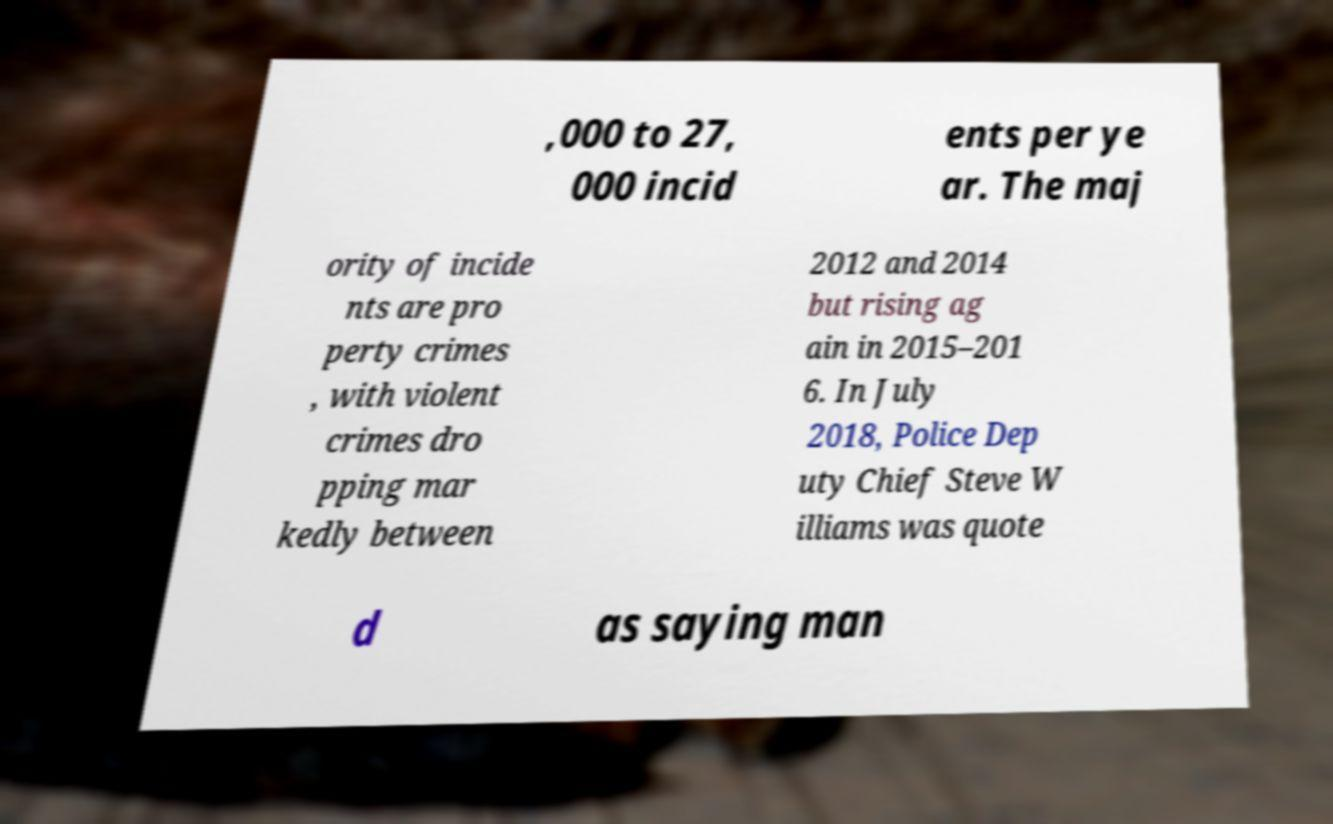Could you assist in decoding the text presented in this image and type it out clearly? ,000 to 27, 000 incid ents per ye ar. The maj ority of incide nts are pro perty crimes , with violent crimes dro pping mar kedly between 2012 and 2014 but rising ag ain in 2015–201 6. In July 2018, Police Dep uty Chief Steve W illiams was quote d as saying man 